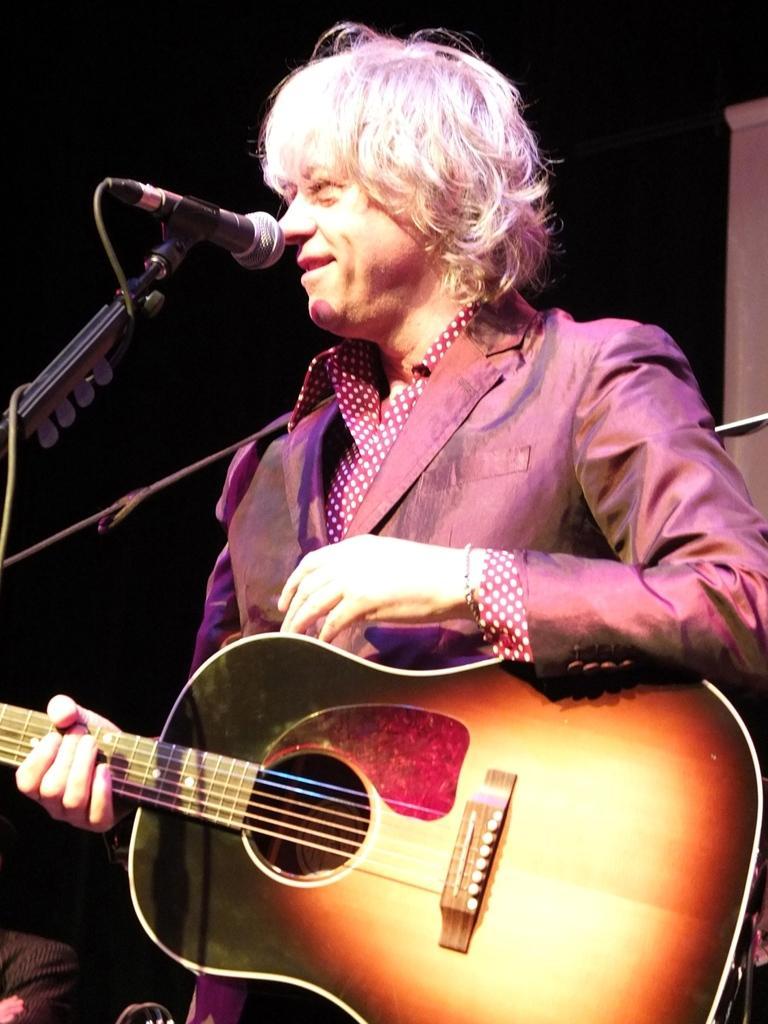Can you describe this image briefly? In this picture we can see a person is standing and smiling, and holding a guitar in his hands, and in front there is the microphone and stand. 